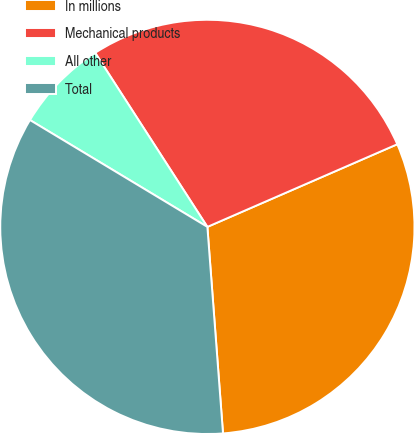Convert chart. <chart><loc_0><loc_0><loc_500><loc_500><pie_chart><fcel>In millions<fcel>Mechanical products<fcel>All other<fcel>Total<nl><fcel>30.33%<fcel>27.58%<fcel>7.26%<fcel>34.83%<nl></chart> 